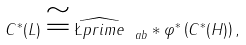Convert formula to latex. <formula><loc_0><loc_0><loc_500><loc_500>C ^ { * } ( L ) \cong \widehat { \L p r i m e } _ { \ a b } * \varphi ^ { * } \left ( C ^ { * } ( H ) \right ) ,</formula> 